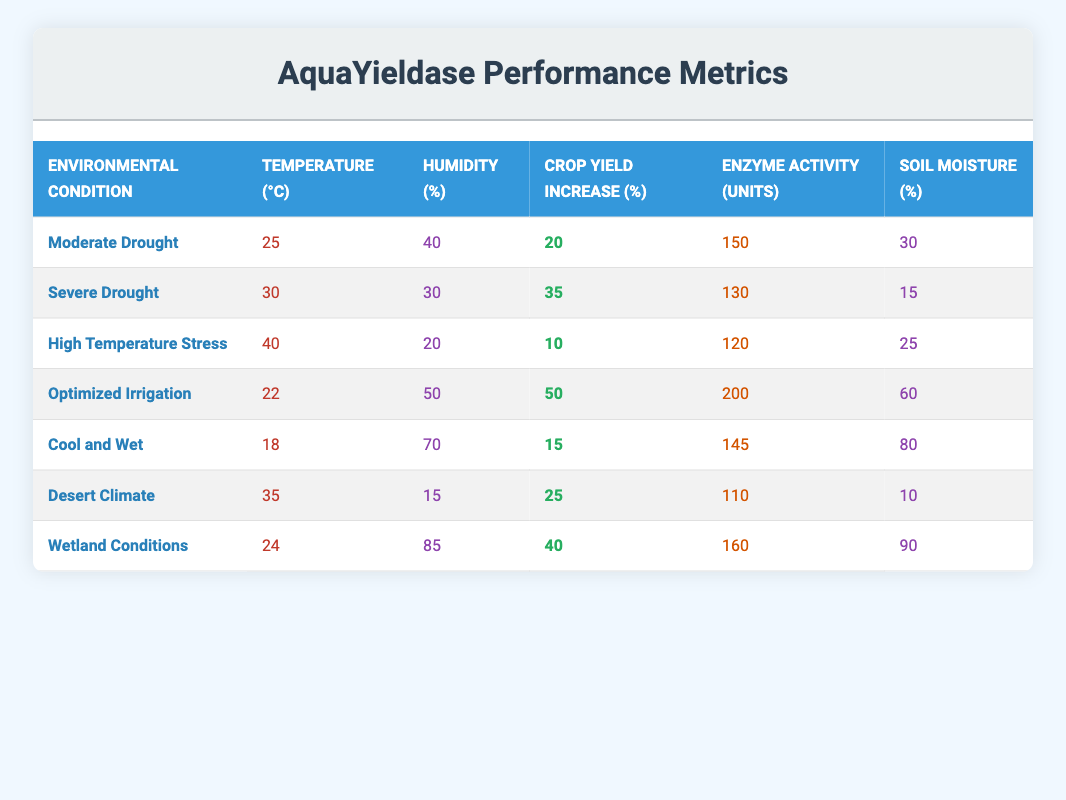What is the crop yield increase percentage under Moderate Drought conditions? In the row for "Moderate Drought," the crop yield increase percentage value is explicitly listed in the table.
Answer: 20 What is the enzyme activity in units for Wetland Conditions? Referring to the row for "Wetland Conditions," the enzyme activity value is provided in the table.
Answer: 160 Which environmental condition shows the highest crop yield increase percentage? By comparing all crop yield increase percentages listed for each environmental condition, "Optimized Irrigation" stands out with a percentage of 50, which is the highest among them.
Answer: Optimized Irrigation Is there any condition where the humidity percentage is below 20%? Looking through the humidity percentage values in the table, all listed conditions show a percentage that is at least 15% or higher.
Answer: No What is the average enzyme activity across all environmental conditions? To find the average enzyme activity, sum up all the enzyme activity values: 150 + 130 + 120 + 200 + 145 + 110 + 160 = 1115. There are 7 data points, so the average is 1115/7 ≈ 159.29.
Answer: Approximately 159.29 How does the crop yield increase percentage under Desert Climate compare with that under High Temperature Stress? Comparing the crop yield increase percentages, Desert Climate shows a 25% increase while High Temperature Stress shows a 10% increase, indicating that Desert Climate has a higher yield increase by 15%.
Answer: Desert Climate is higher by 15% What percentage of soil moisture is observed in conditions of Severe Drought? For the environmental condition labeled "Severe Drought," the soil moisture percentage is documented directly in the corresponding row of the table.
Answer: 15 Which environmental condition has both the lowest humidity and the lowest crop yield increase percentage? By examining the data, "Desert Climate" has the lowest humidity percentage at 15% and a crop yield increase percentage of 25%, making it the only condition with both low values.
Answer: Desert Climate In which environmental condition does enzyme activity decrease below 120 units? Looking at the enzyme activity unit values, "High Temperature Stress" and "Desert Climate" are the conditions where enzyme activity is below 120, specifically at 120 and 110, respectively.
Answer: High Temperature Stress and Desert Climate 